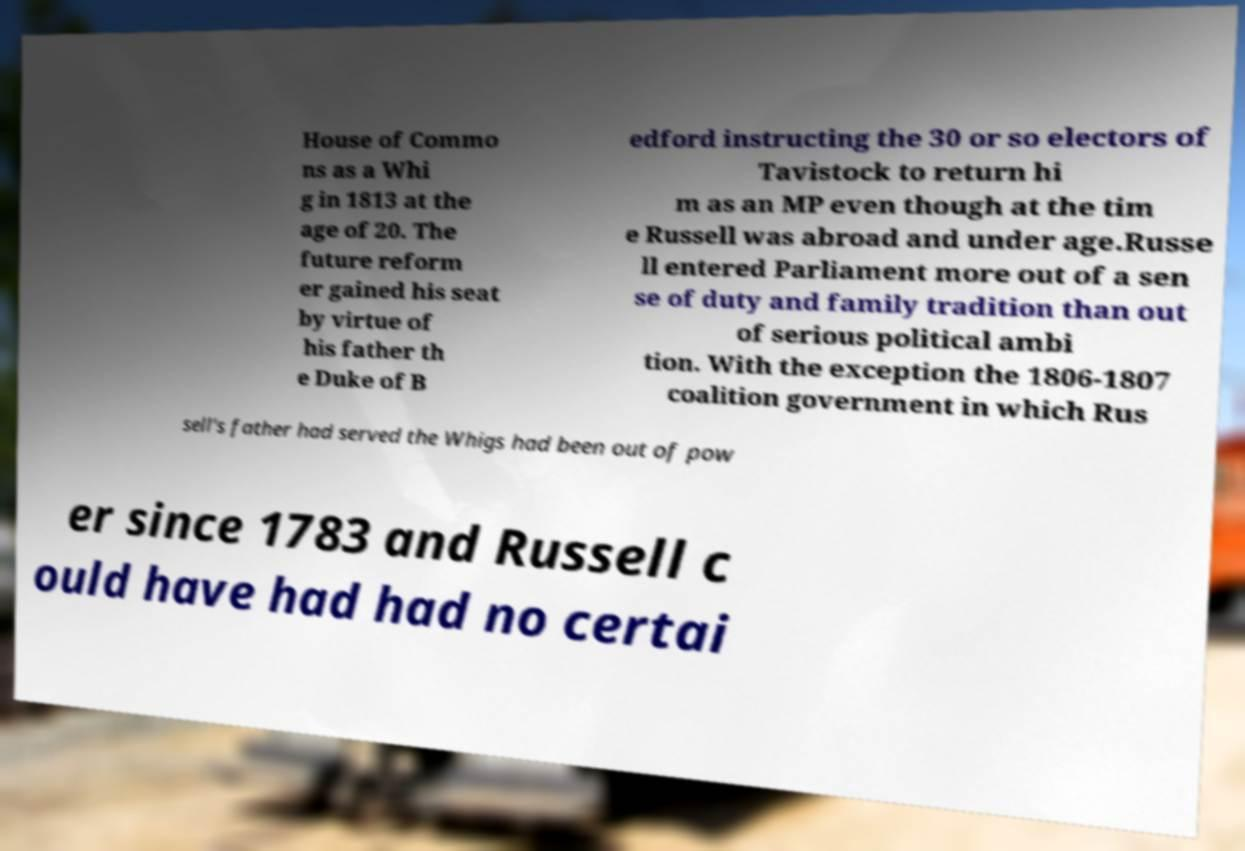Please identify and transcribe the text found in this image. House of Commo ns as a Whi g in 1813 at the age of 20. The future reform er gained his seat by virtue of his father th e Duke of B edford instructing the 30 or so electors of Tavistock to return hi m as an MP even though at the tim e Russell was abroad and under age.Russe ll entered Parliament more out of a sen se of duty and family tradition than out of serious political ambi tion. With the exception the 1806-1807 coalition government in which Rus sell's father had served the Whigs had been out of pow er since 1783 and Russell c ould have had had no certai 